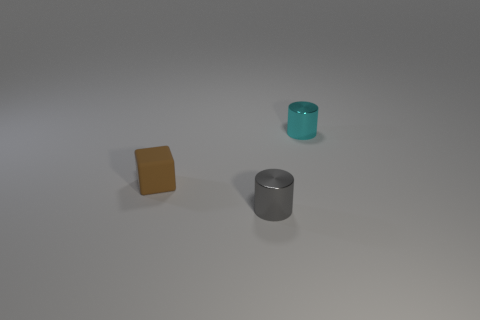Imagine this is part of a minimalistic art installation. What might the artist be trying to convey with these objects? If this were a minimalistic art installation, the artist could be exploring the interplay between different geometric shapes and materials, as well as the contrasting textures and colors. The composition invites the viewer to consider simplicity, balance, and the beauty of everyday objects when seen through a lens that strips away their functionality. 